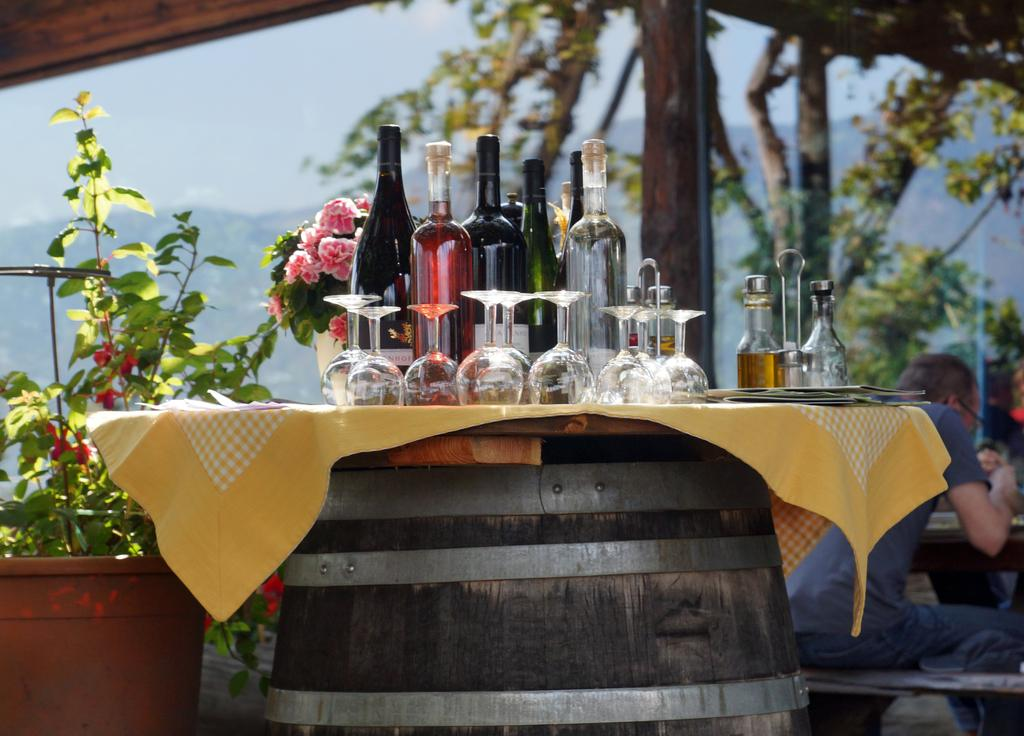What is present on the table in the image? There are glasses and bottles on the table in the image. What can be seen in the background of the image? There are plants, trees, and a person sitting in the background of the image. How does the person in the background of the image contribute to pollution? There is no information about the person's actions or activities in the image, so it cannot be determined if they contribute to pollution. 